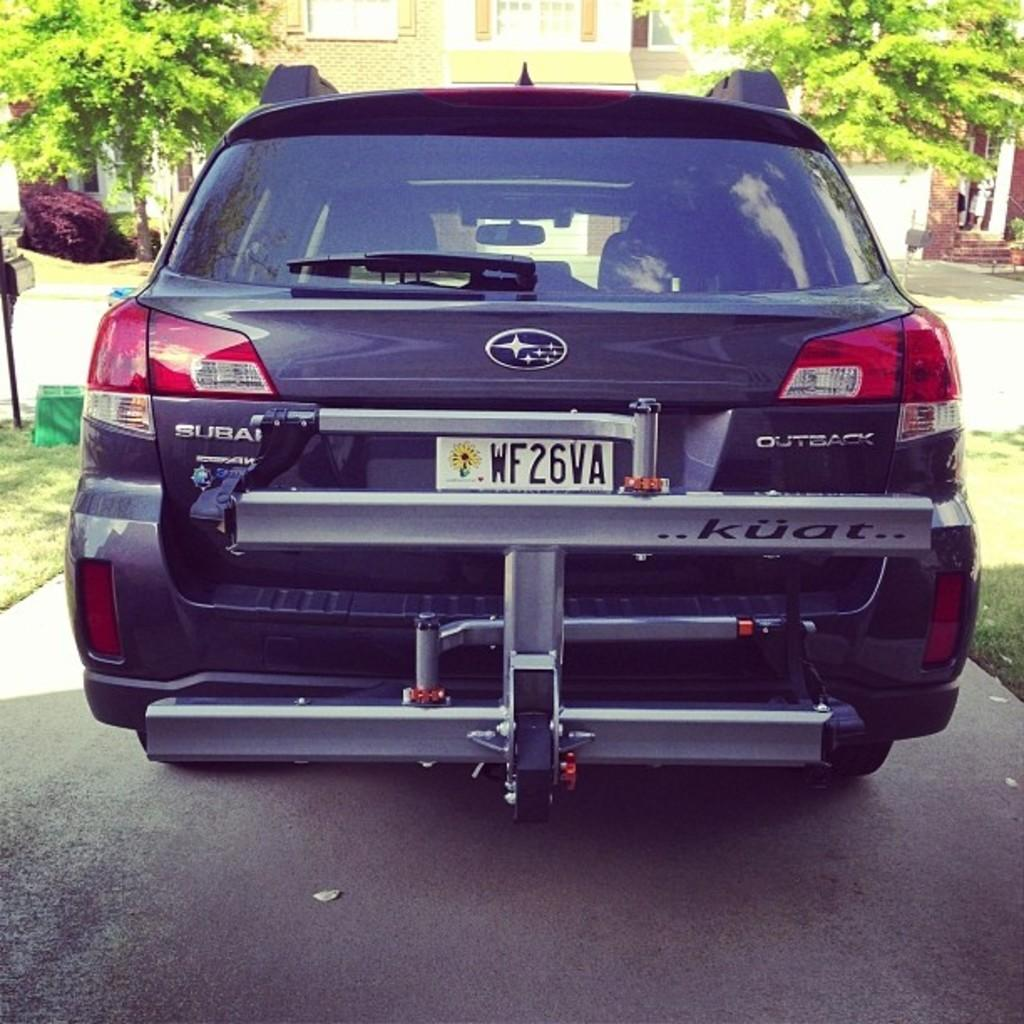<image>
Present a compact description of the photo's key features. A purple Subaru has a lift from kuat attached to the back 